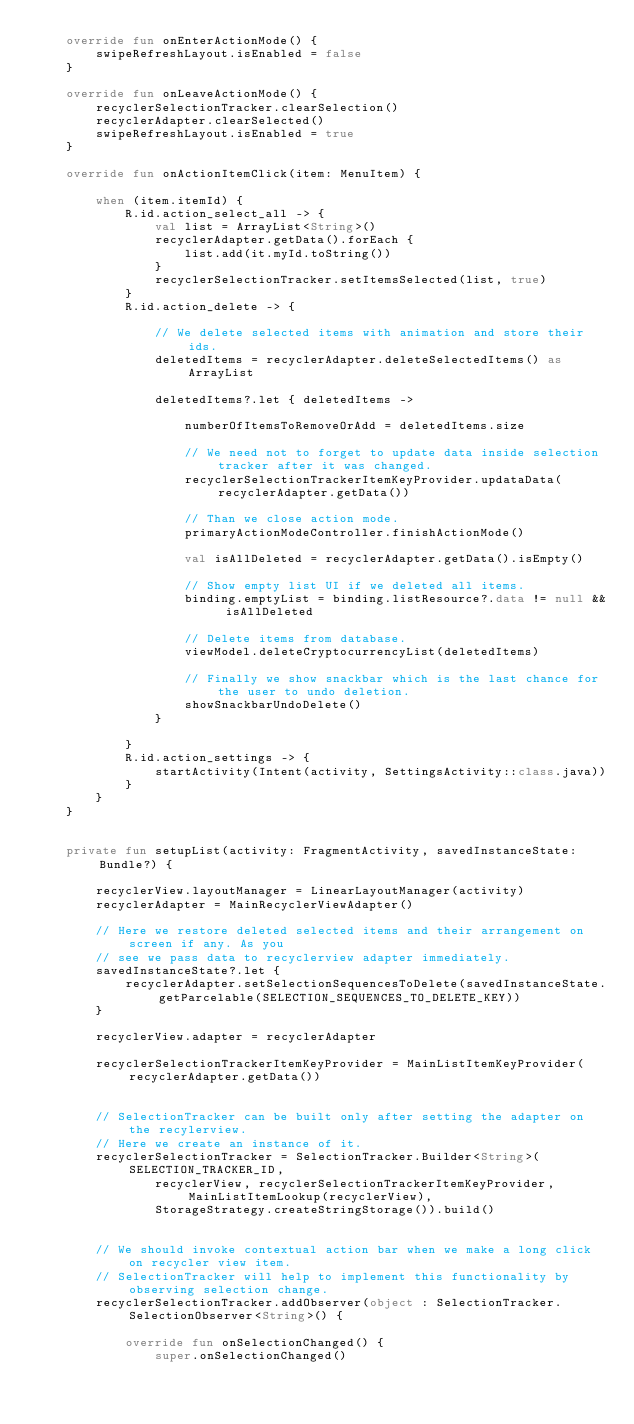<code> <loc_0><loc_0><loc_500><loc_500><_Kotlin_>    override fun onEnterActionMode() {
        swipeRefreshLayout.isEnabled = false
    }

    override fun onLeaveActionMode() {
        recyclerSelectionTracker.clearSelection()
        recyclerAdapter.clearSelected()
        swipeRefreshLayout.isEnabled = true
    }

    override fun onActionItemClick(item: MenuItem) {

        when (item.itemId) {
            R.id.action_select_all -> {
                val list = ArrayList<String>()
                recyclerAdapter.getData().forEach {
                    list.add(it.myId.toString())
                }
                recyclerSelectionTracker.setItemsSelected(list, true)
            }
            R.id.action_delete -> {

                // We delete selected items with animation and store their ids.
                deletedItems = recyclerAdapter.deleteSelectedItems() as ArrayList

                deletedItems?.let { deletedItems ->

                    numberOfItemsToRemoveOrAdd = deletedItems.size

                    // We need not to forget to update data inside selection tracker after it was changed.
                    recyclerSelectionTrackerItemKeyProvider.updataData(recyclerAdapter.getData())

                    // Than we close action mode.
                    primaryActionModeController.finishActionMode()

                    val isAllDeleted = recyclerAdapter.getData().isEmpty()

                    // Show empty list UI if we deleted all items.
                    binding.emptyList = binding.listResource?.data != null && isAllDeleted

                    // Delete items from database.
                    viewModel.deleteCryptocurrencyList(deletedItems)

                    // Finally we show snackbar which is the last chance for the user to undo deletion.
                    showSnackbarUndoDelete()
                }

            }
            R.id.action_settings -> {
                startActivity(Intent(activity, SettingsActivity::class.java))
            }
        }
    }


    private fun setupList(activity: FragmentActivity, savedInstanceState: Bundle?) {

        recyclerView.layoutManager = LinearLayoutManager(activity)
        recyclerAdapter = MainRecyclerViewAdapter()

        // Here we restore deleted selected items and their arrangement on screen if any. As you
        // see we pass data to recyclerview adapter immediately.
        savedInstanceState?.let {
            recyclerAdapter.setSelectionSequencesToDelete(savedInstanceState.getParcelable(SELECTION_SEQUENCES_TO_DELETE_KEY))
        }

        recyclerView.adapter = recyclerAdapter

        recyclerSelectionTrackerItemKeyProvider = MainListItemKeyProvider(recyclerAdapter.getData())


        // SelectionTracker can be built only after setting the adapter on the recylerview.
        // Here we create an instance of it.
        recyclerSelectionTracker = SelectionTracker.Builder<String>(SELECTION_TRACKER_ID,
                recyclerView, recyclerSelectionTrackerItemKeyProvider, MainListItemLookup(recyclerView),
                StorageStrategy.createStringStorage()).build()


        // We should invoke contextual action bar when we make a long click on recycler view item.
        // SelectionTracker will help to implement this functionality by observing selection change.
        recyclerSelectionTracker.addObserver(object : SelectionTracker.SelectionObserver<String>() {

            override fun onSelectionChanged() {
                super.onSelectionChanged()</code> 